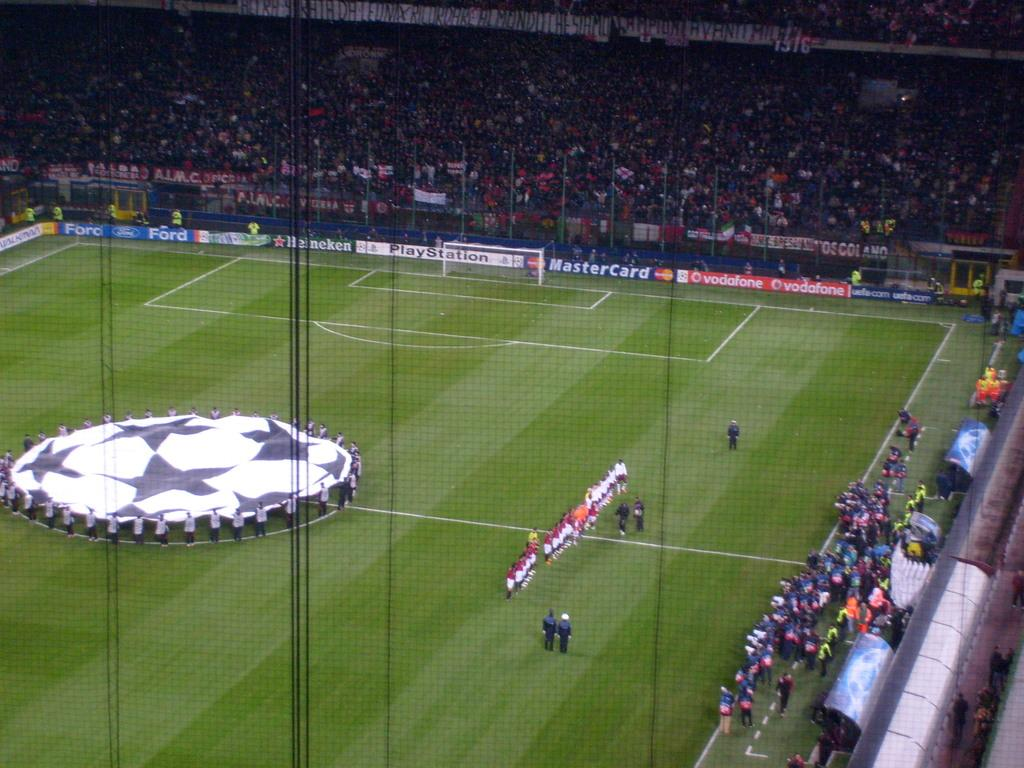<image>
Give a short and clear explanation of the subsequent image. A soccer stadium features an advertisement for Master Card. 